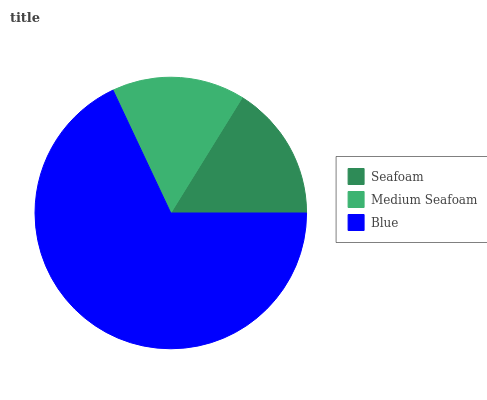Is Medium Seafoam the minimum?
Answer yes or no. Yes. Is Blue the maximum?
Answer yes or no. Yes. Is Blue the minimum?
Answer yes or no. No. Is Medium Seafoam the maximum?
Answer yes or no. No. Is Blue greater than Medium Seafoam?
Answer yes or no. Yes. Is Medium Seafoam less than Blue?
Answer yes or no. Yes. Is Medium Seafoam greater than Blue?
Answer yes or no. No. Is Blue less than Medium Seafoam?
Answer yes or no. No. Is Seafoam the high median?
Answer yes or no. Yes. Is Seafoam the low median?
Answer yes or no. Yes. Is Medium Seafoam the high median?
Answer yes or no. No. Is Blue the low median?
Answer yes or no. No. 